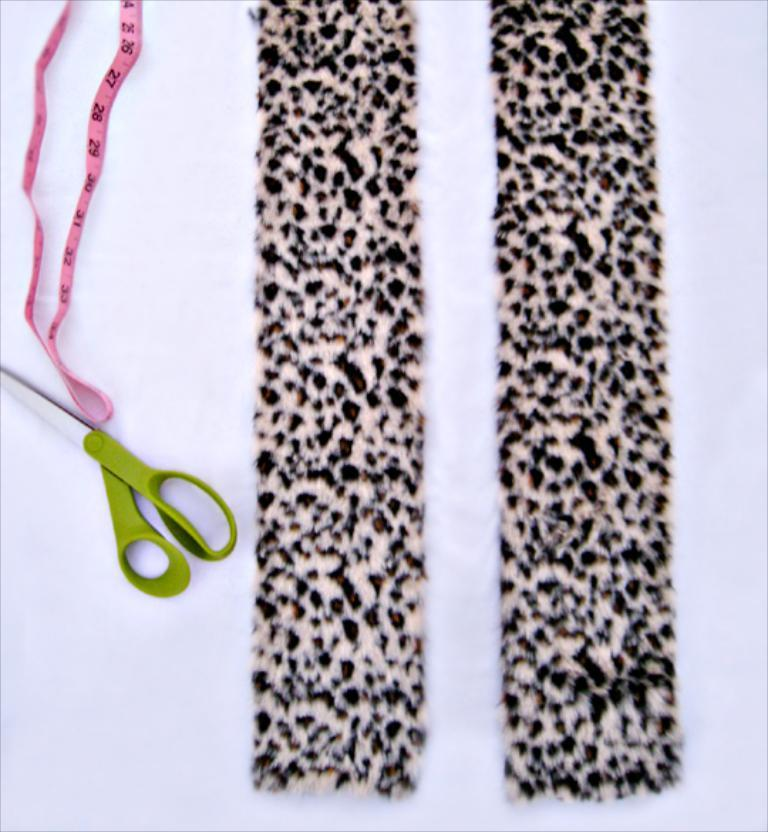What type of scissors can be seen in the image? There is a green scissors in the image. What other item is present in the image that is used for binding or attaching? There is pink color tape in the image. What is the color and pattern of the cloth in the image? The cloth has cream and black colors. On what surface are the objects placed in the image? The objects are on a white color surface. What type of jewel is placed on the guitar in the image? There is no guitar or jewel present in the image. 